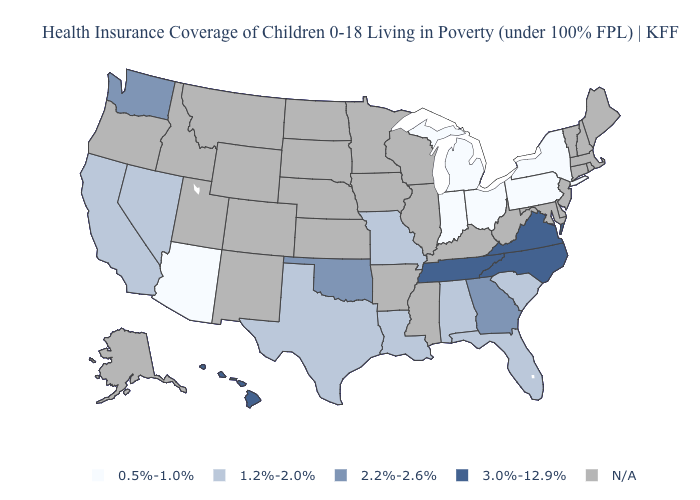What is the value of Mississippi?
Short answer required. N/A. Name the states that have a value in the range 1.2%-2.0%?
Concise answer only. Alabama, California, Florida, Louisiana, Missouri, Nevada, South Carolina, Texas. What is the highest value in the West ?
Keep it brief. 3.0%-12.9%. What is the highest value in the West ?
Answer briefly. 3.0%-12.9%. Name the states that have a value in the range 0.5%-1.0%?
Keep it brief. Arizona, Indiana, Michigan, New York, Ohio, Pennsylvania. What is the highest value in the USA?
Keep it brief. 3.0%-12.9%. Does Arizona have the lowest value in the USA?
Write a very short answer. Yes. What is the lowest value in the USA?
Concise answer only. 0.5%-1.0%. What is the lowest value in the USA?
Answer briefly. 0.5%-1.0%. Name the states that have a value in the range 3.0%-12.9%?
Write a very short answer. Hawaii, North Carolina, Tennessee, Virginia. Does the first symbol in the legend represent the smallest category?
Quick response, please. Yes. How many symbols are there in the legend?
Short answer required. 5. Which states have the lowest value in the South?
Answer briefly. Alabama, Florida, Louisiana, South Carolina, Texas. Is the legend a continuous bar?
Concise answer only. No. What is the lowest value in states that border Colorado?
Concise answer only. 0.5%-1.0%. 